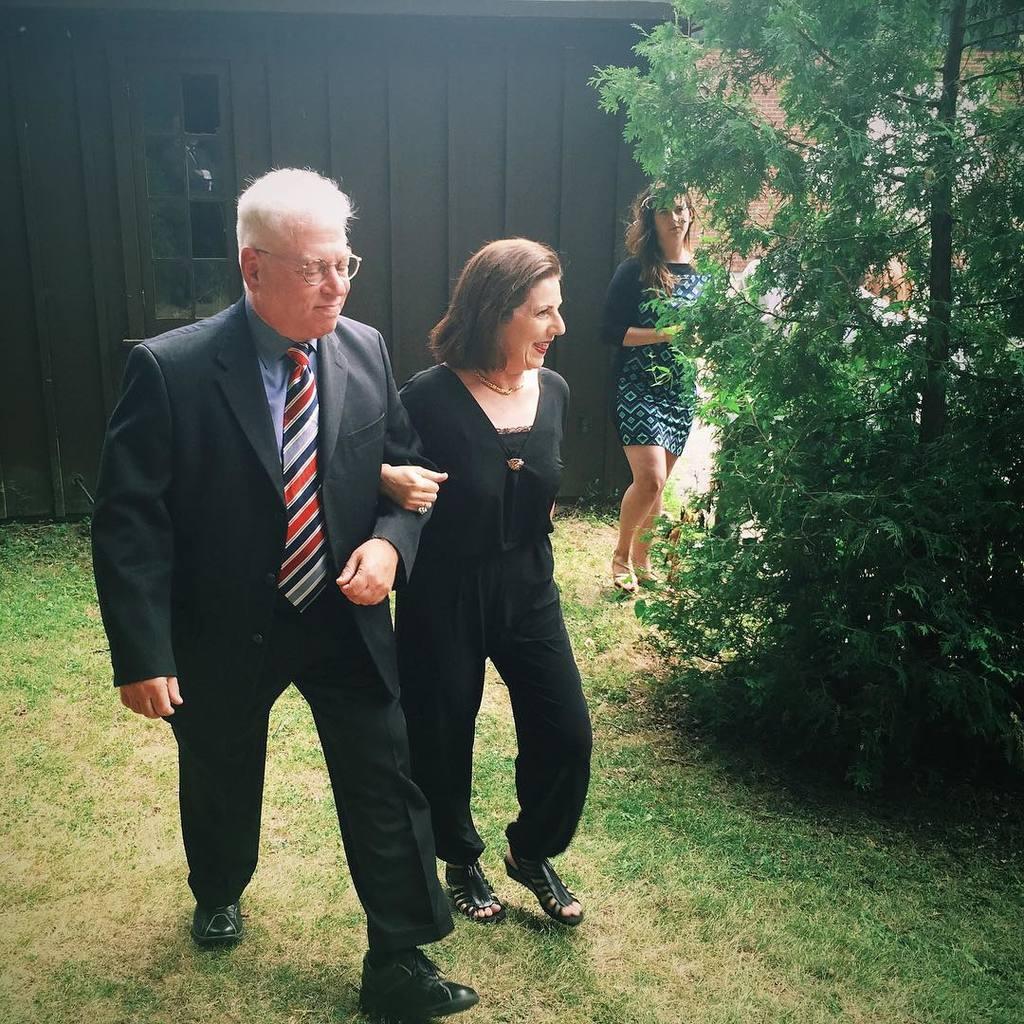Please provide a concise description of this image. in the image in the center we can see two persons walking and they were smiling,which we can see on their faces. In the background we can see wall,trees,grass and one woman standing. 